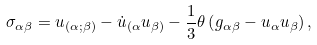Convert formula to latex. <formula><loc_0><loc_0><loc_500><loc_500>\sigma _ { \alpha \beta } = u _ { ( \alpha ; \beta ) } - \dot { u } _ { ( \alpha } u _ { \beta ) } - \frac { 1 } { 3 } \theta \left ( g _ { \alpha \beta } - u _ { \alpha } u _ { \beta } \right ) ,</formula> 